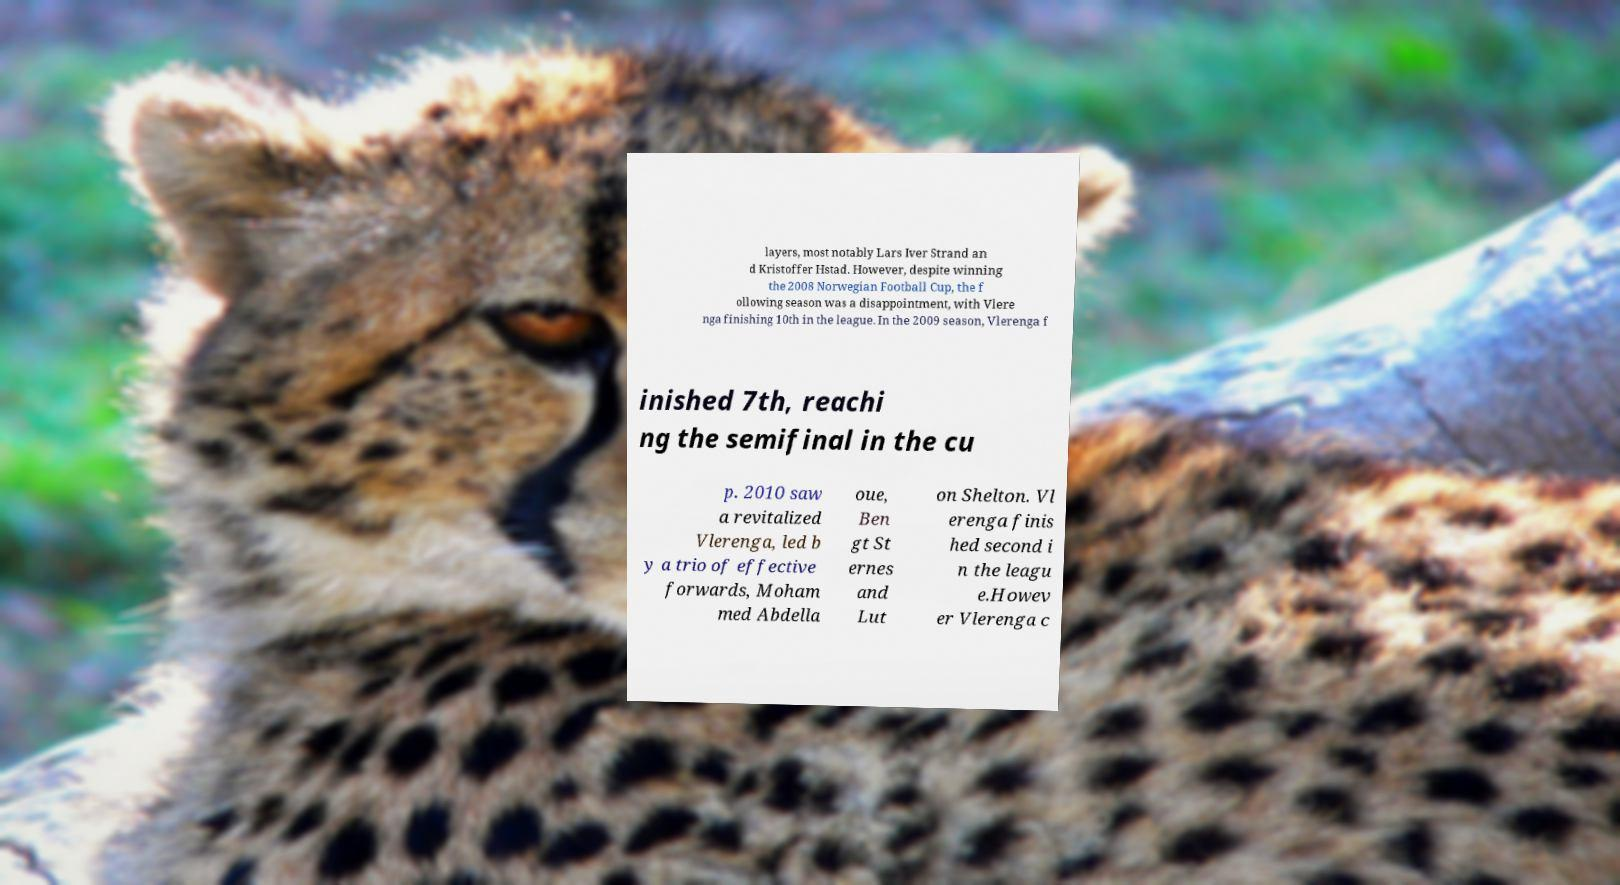Please identify and transcribe the text found in this image. layers, most notably Lars Iver Strand an d Kristoffer Hstad. However, despite winning the 2008 Norwegian Football Cup, the f ollowing season was a disappointment, with Vlere nga finishing 10th in the league. In the 2009 season, Vlerenga f inished 7th, reachi ng the semifinal in the cu p. 2010 saw a revitalized Vlerenga, led b y a trio of effective forwards, Moham med Abdella oue, Ben gt St ernes and Lut on Shelton. Vl erenga finis hed second i n the leagu e.Howev er Vlerenga c 